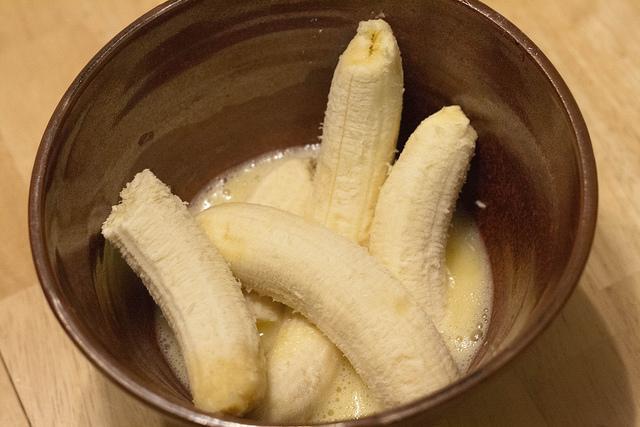Is the statement "The bowl is on the dining table." accurate regarding the image?
Answer yes or no. Yes. 